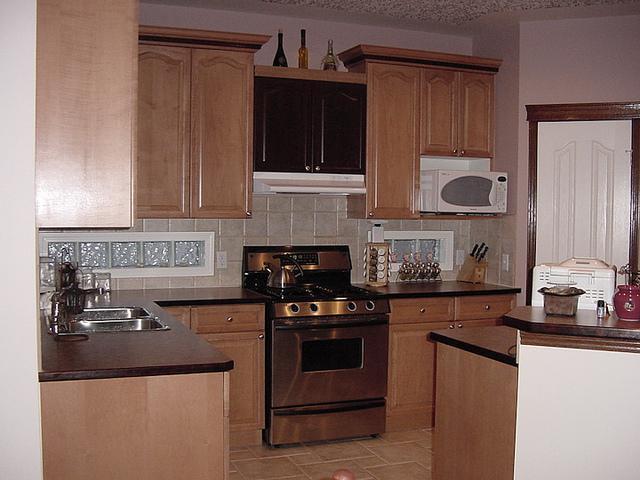How many drawers are in the kitchen?
Give a very brief answer. 4. How many trucks are there?
Give a very brief answer. 0. 